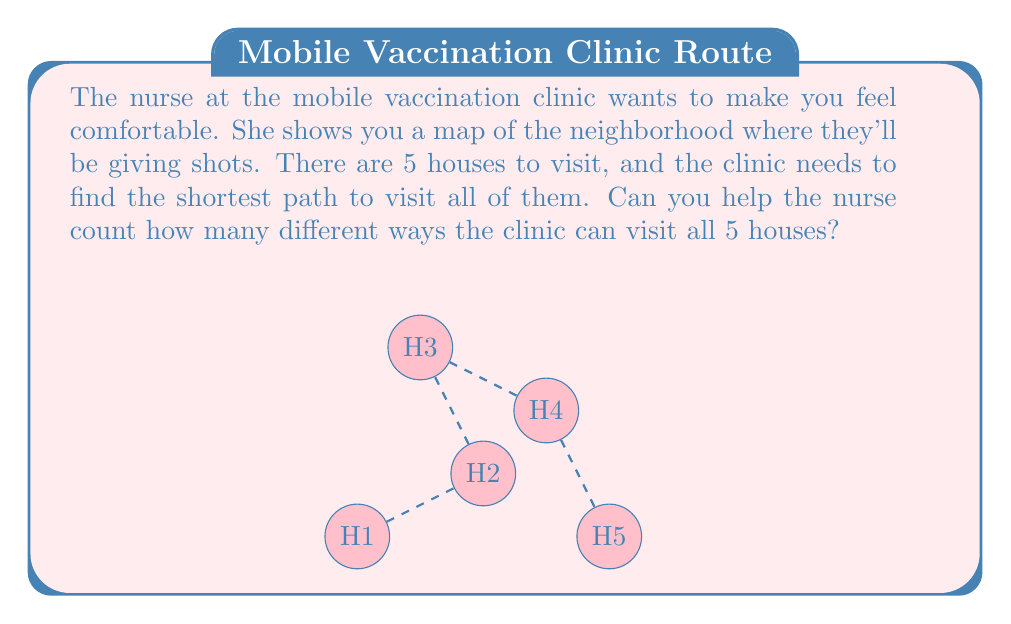Solve this math problem. Let's approach this step-by-step:

1) First, we need to understand what the question is asking. We're looking for the number of different ways to visit 5 houses in different orders.

2) This is a permutation problem. We're arranging 5 items (houses) in different orders.

3) The formula for permutations of $n$ distinct objects is:

   $$P(n) = n!$$

   Where $n!$ (n factorial) is the product of all positive integers less than or equal to $n$.

4) In this case, $n = 5$, so we need to calculate $5!$:

   $$5! = 5 \times 4 \times 3 \times 2 \times 1 = 120$$

5) Therefore, there are 120 different ways the mobile vaccination clinic can visit all 5 houses.

This might seem like a big number, but remember, the nurse is just trying to show you how many options they have to plan their route. They'll choose the best one to make sure everyone gets their shots as quickly and efficiently as possible.
Answer: 120 ways 